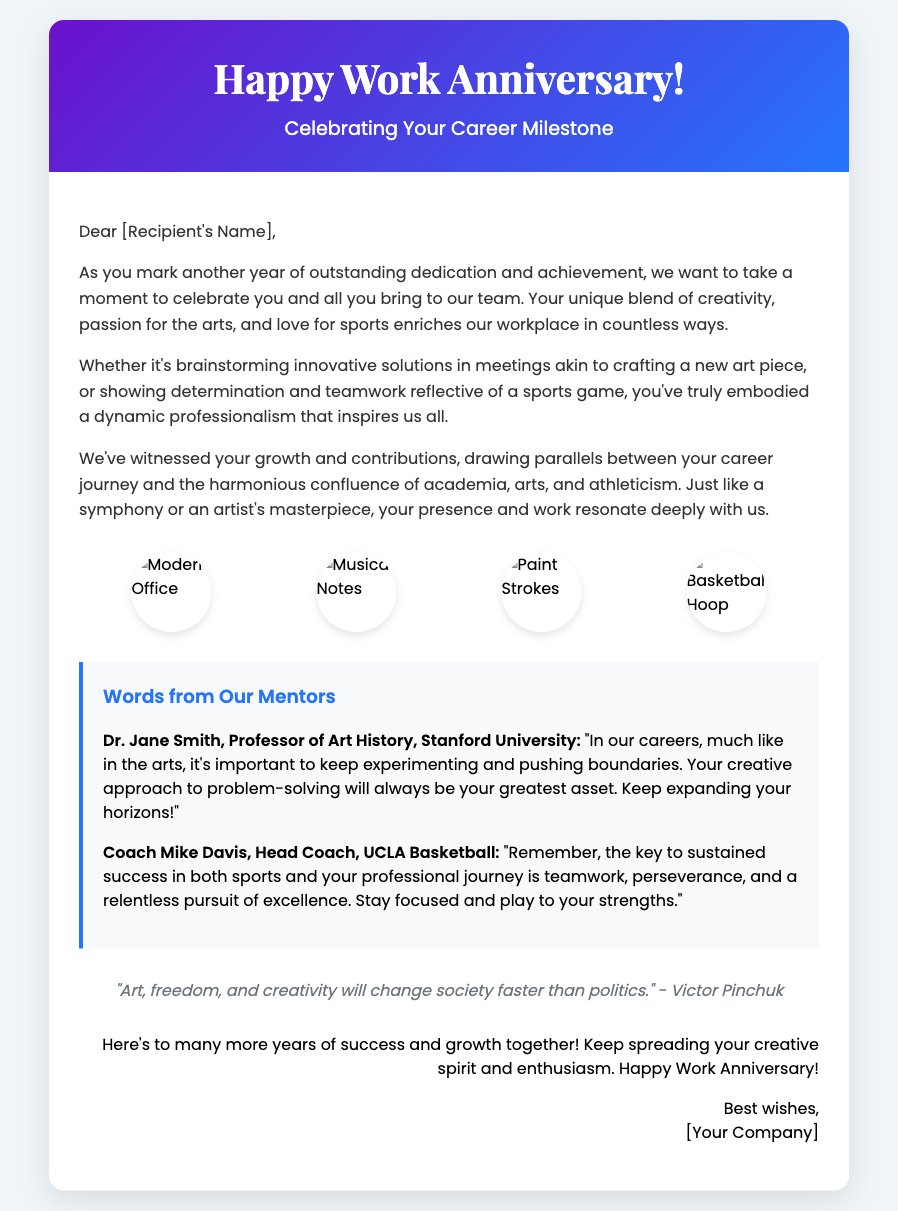What is the title of the card? The title is prominently displayed in the header section of the card as a celebration of the occasion.
Answer: Happy Work Anniversary! Who is the recipient of the card? The recipient's name is specified in the greeting within the message section that is addressed directly to them.
Answer: [Recipient's Name] What symbolizes the recipient's varied interests in the graphics? The graphics include elements that represent the recipient's interests in arts and sports, enhancing the visual appeal of the card.
Answer: Musical notes and paint strokes How many quotes are included in the card? The card features one quote that emphasizes the power of art and creativity.
Answer: One What professions do the mentors quoted in the card hold? The professions are explicitly mentioned alongside the names of the mentors, showcasing their expertise.
Answer: Professor of Art History and Head Coach What is the theme of the message in the card? The message celebrates the recipient's contributions while drawing parallels between their career and their creative and athletic interests.
Answer: Celebration of career milestone How does the card visually represent teamwork? The card visually represents teamwork through imagery and messages that resonate with collaborative success in both creative and athletic fields.
Answer: Basketball Hoop Who is the author of the quote in the card? The quote at the bottom of the card attributes its thought to a well-known figure, highlighting its relevance.
Answer: Victor Pinchuk 